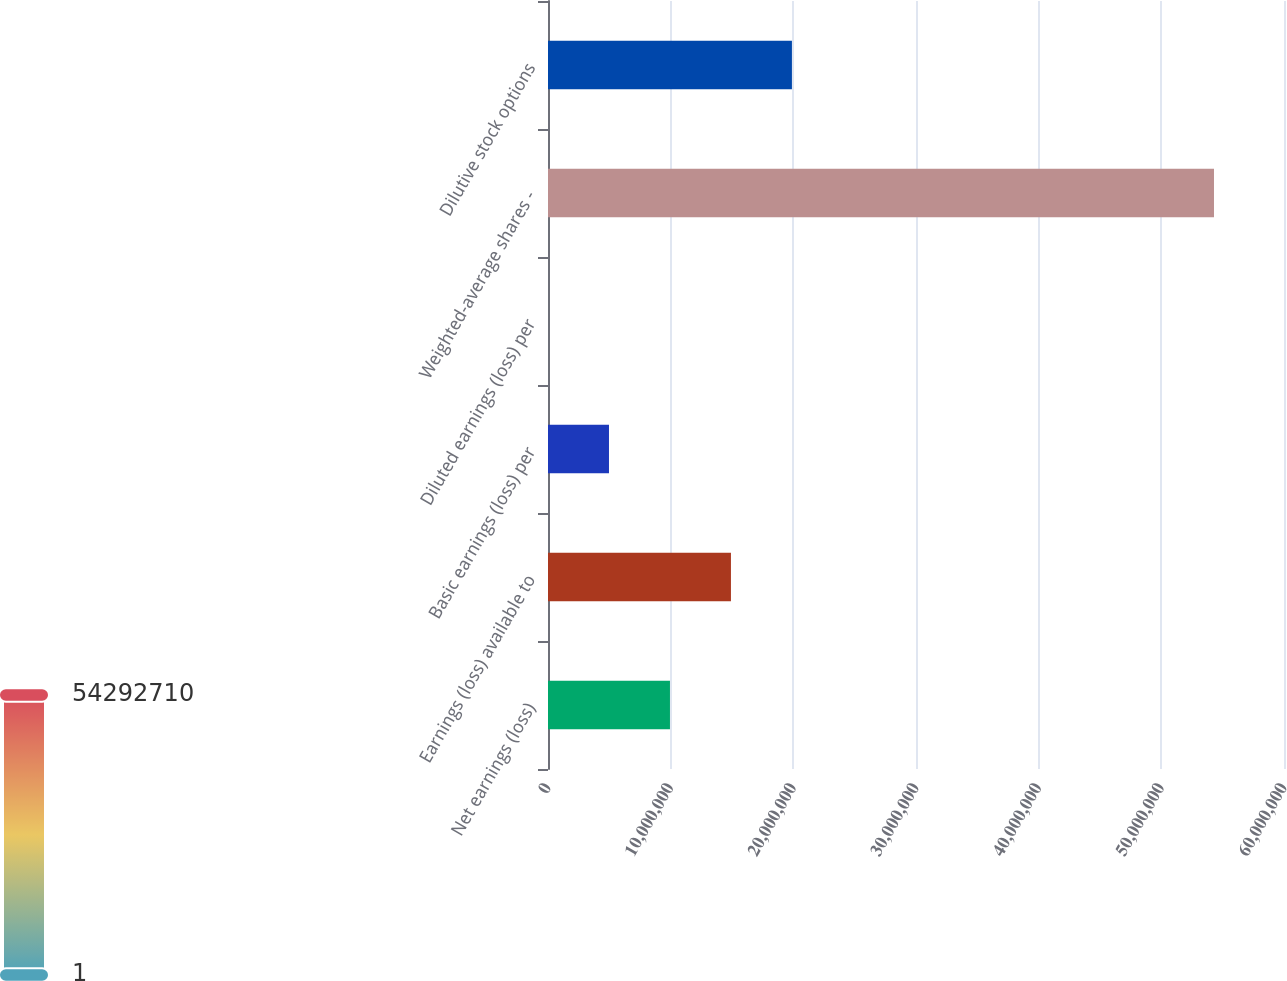Convert chart to OTSL. <chart><loc_0><loc_0><loc_500><loc_500><bar_chart><fcel>Net earnings (loss)<fcel>Earnings (loss) available to<fcel>Basic earnings (loss) per<fcel>Diluted earnings (loss) per<fcel>Weighted-average shares -<fcel>Dilutive stock options<nl><fcel>9.94248e+06<fcel>1.49137e+07<fcel>4.97124e+06<fcel>0.52<fcel>5.42927e+07<fcel>1.9885e+07<nl></chart> 